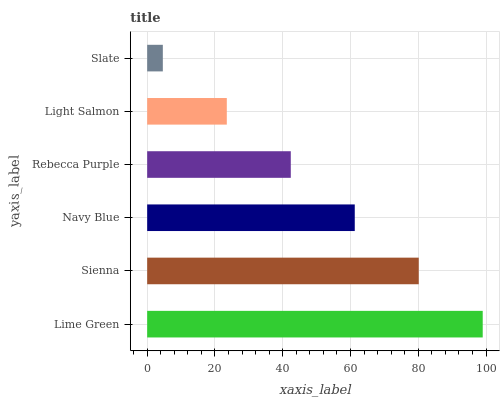Is Slate the minimum?
Answer yes or no. Yes. Is Lime Green the maximum?
Answer yes or no. Yes. Is Sienna the minimum?
Answer yes or no. No. Is Sienna the maximum?
Answer yes or no. No. Is Lime Green greater than Sienna?
Answer yes or no. Yes. Is Sienna less than Lime Green?
Answer yes or no. Yes. Is Sienna greater than Lime Green?
Answer yes or no. No. Is Lime Green less than Sienna?
Answer yes or no. No. Is Navy Blue the high median?
Answer yes or no. Yes. Is Rebecca Purple the low median?
Answer yes or no. Yes. Is Light Salmon the high median?
Answer yes or no. No. Is Sienna the low median?
Answer yes or no. No. 